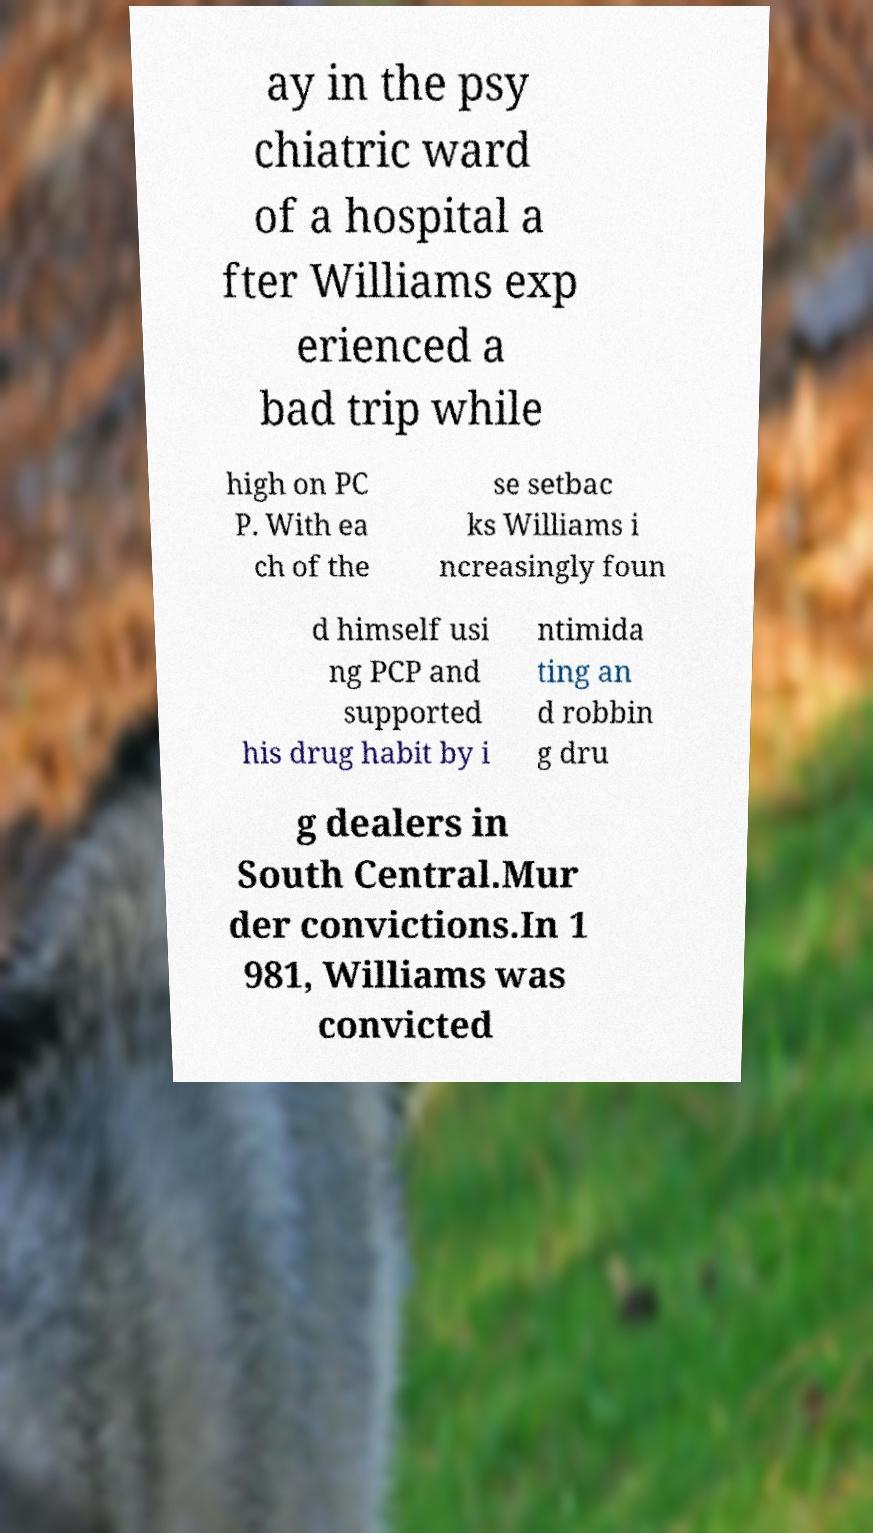I need the written content from this picture converted into text. Can you do that? ay in the psy chiatric ward of a hospital a fter Williams exp erienced a bad trip while high on PC P. With ea ch of the se setbac ks Williams i ncreasingly foun d himself usi ng PCP and supported his drug habit by i ntimida ting an d robbin g dru g dealers in South Central.Mur der convictions.In 1 981, Williams was convicted 